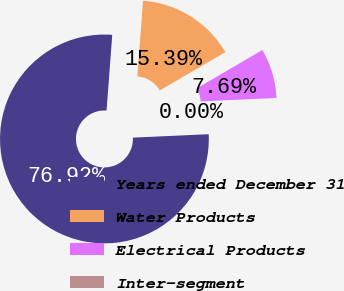Convert chart. <chart><loc_0><loc_0><loc_500><loc_500><pie_chart><fcel>Years ended December 31<fcel>Water Products<fcel>Electrical Products<fcel>Inter-segment<nl><fcel>76.92%<fcel>15.39%<fcel>7.69%<fcel>0.0%<nl></chart> 